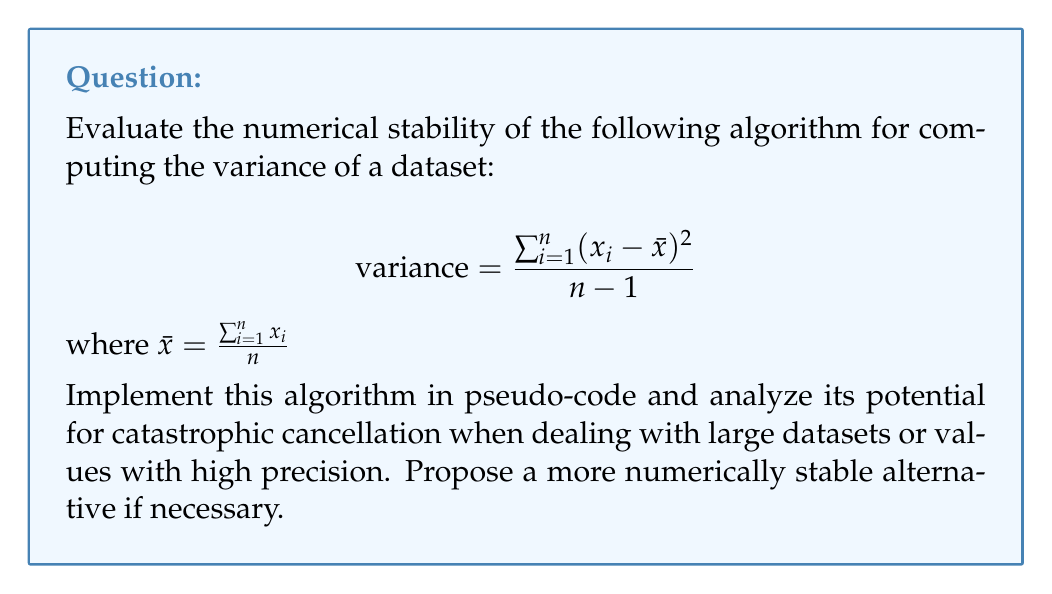Can you answer this question? To assess the numerical stability of this variance computation algorithm, we need to consider the following steps:

1. Implement the algorithm in pseudo-code:

```
function compute_variance(x):
    n = length(x)
    mean = sum(x) / n
    squared_diff_sum = 0
    for i in 1 to n:
        squared_diff_sum += (x[i] - mean)^2
    variance = squared_diff_sum / (n - 1)
    return variance
```

2. Analyze potential issues:

The main concern with this algorithm is the potential for catastrophic cancellation when computing $(x_i - \bar{x})^2$, especially for large datasets or high-precision values. When $x_i$ and $\bar{x}$ are close in value, subtracting them can lead to a significant loss of precision.

3. Consider a more stable alternative:

A numerically stable algorithm for computing variance is the two-pass algorithm, which uses the following formula:

$$\text{variance} = \frac{\sum_{i=1}^n x_i^2 - \frac{1}{n}(\sum_{i=1}^n x_i)^2}{n-1}$$

This can be implemented as:

```
function compute_stable_variance(x):
    n = length(x)
    sum_x = 0
    sum_x_squared = 0
    for i in 1 to n:
        sum_x += x[i]
        sum_x_squared += x[i]^2
    variance = (sum_x_squared - (sum_x^2 / n)) / (n - 1)
    return variance
```

This algorithm is more numerically stable because it avoids the subtraction of similar values, reducing the risk of catastrophic cancellation.

4. Comparison of stability:

The two-pass algorithm is generally more stable, especially for large datasets or high-precision values. However, it requires two passes through the data and may be slightly slower for very large datasets.

5. Recommendation:

For a rigorous code review focused on numerical stability, it is recommended to use the two-pass algorithm or consider even more sophisticated methods like the Welford's online algorithm for very large datasets or streaming data.
Answer: The original algorithm is potentially unstable due to catastrophic cancellation. A more numerically stable alternative is the two-pass algorithm: $\text{variance} = \frac{\sum_{i=1}^n x_i^2 - \frac{1}{n}(\sum_{i=1}^n x_i)^2}{n-1}$ 